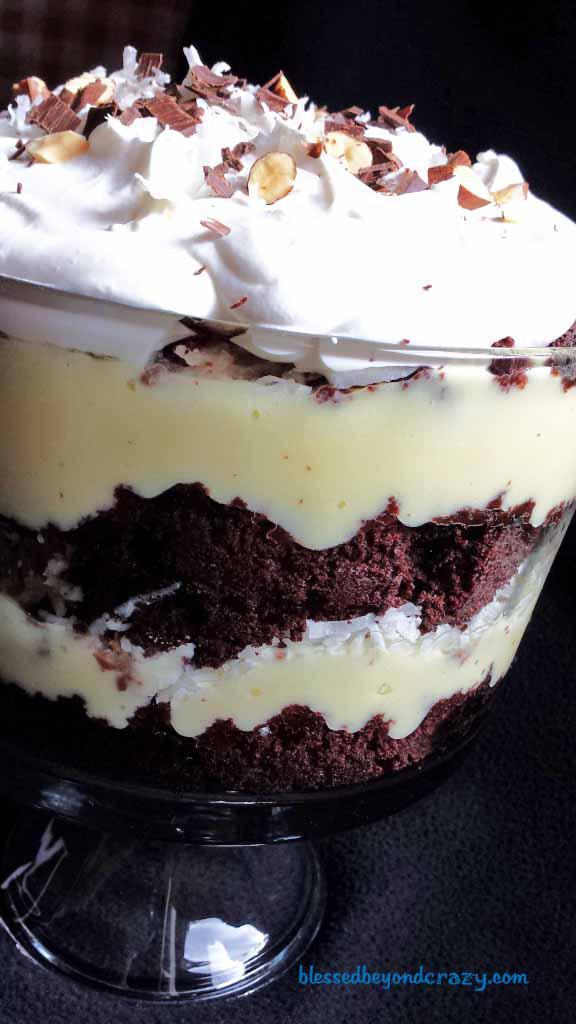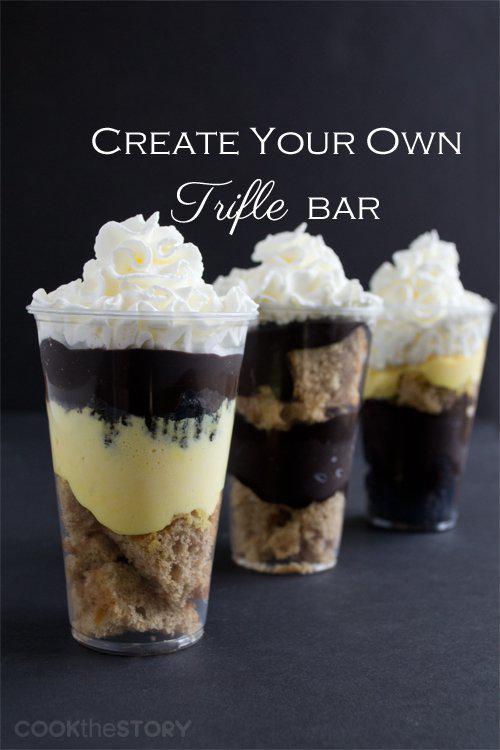The first image is the image on the left, the second image is the image on the right. Given the left and right images, does the statement "One of the images features three trifle desserts served individually." hold true? Answer yes or no. Yes. 